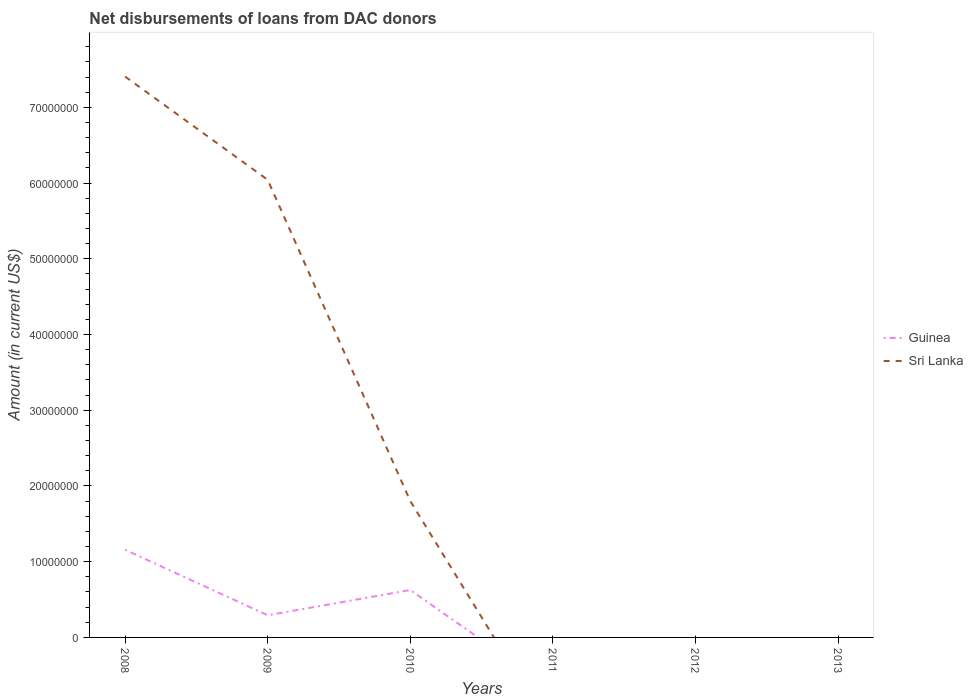Is the number of lines equal to the number of legend labels?
Your response must be concise. No. Across all years, what is the maximum amount of loans disbursed in Guinea?
Your answer should be very brief. 0. What is the difference between the highest and the second highest amount of loans disbursed in Sri Lanka?
Your response must be concise. 7.41e+07. What is the difference between the highest and the lowest amount of loans disbursed in Sri Lanka?
Provide a short and direct response. 2. Is the amount of loans disbursed in Sri Lanka strictly greater than the amount of loans disbursed in Guinea over the years?
Your answer should be compact. No. Are the values on the major ticks of Y-axis written in scientific E-notation?
Provide a short and direct response. No. How are the legend labels stacked?
Your response must be concise. Vertical. What is the title of the graph?
Give a very brief answer. Net disbursements of loans from DAC donors. What is the Amount (in current US$) of Guinea in 2008?
Your response must be concise. 1.16e+07. What is the Amount (in current US$) of Sri Lanka in 2008?
Your response must be concise. 7.41e+07. What is the Amount (in current US$) of Guinea in 2009?
Ensure brevity in your answer.  2.93e+06. What is the Amount (in current US$) of Sri Lanka in 2009?
Your answer should be very brief. 6.04e+07. What is the Amount (in current US$) of Guinea in 2010?
Make the answer very short. 6.26e+06. What is the Amount (in current US$) of Sri Lanka in 2010?
Your answer should be compact. 1.80e+07. What is the Amount (in current US$) of Guinea in 2011?
Ensure brevity in your answer.  0. What is the Amount (in current US$) of Sri Lanka in 2012?
Provide a succinct answer. 0. Across all years, what is the maximum Amount (in current US$) in Guinea?
Offer a very short reply. 1.16e+07. Across all years, what is the maximum Amount (in current US$) in Sri Lanka?
Provide a succinct answer. 7.41e+07. Across all years, what is the minimum Amount (in current US$) of Guinea?
Ensure brevity in your answer.  0. Across all years, what is the minimum Amount (in current US$) of Sri Lanka?
Make the answer very short. 0. What is the total Amount (in current US$) in Guinea in the graph?
Keep it short and to the point. 2.08e+07. What is the total Amount (in current US$) of Sri Lanka in the graph?
Give a very brief answer. 1.52e+08. What is the difference between the Amount (in current US$) of Guinea in 2008 and that in 2009?
Your answer should be compact. 8.64e+06. What is the difference between the Amount (in current US$) of Sri Lanka in 2008 and that in 2009?
Provide a short and direct response. 1.36e+07. What is the difference between the Amount (in current US$) of Guinea in 2008 and that in 2010?
Your answer should be compact. 5.31e+06. What is the difference between the Amount (in current US$) in Sri Lanka in 2008 and that in 2010?
Give a very brief answer. 5.60e+07. What is the difference between the Amount (in current US$) of Guinea in 2009 and that in 2010?
Offer a terse response. -3.33e+06. What is the difference between the Amount (in current US$) in Sri Lanka in 2009 and that in 2010?
Give a very brief answer. 4.24e+07. What is the difference between the Amount (in current US$) in Guinea in 2008 and the Amount (in current US$) in Sri Lanka in 2009?
Your answer should be very brief. -4.89e+07. What is the difference between the Amount (in current US$) of Guinea in 2008 and the Amount (in current US$) of Sri Lanka in 2010?
Offer a very short reply. -6.44e+06. What is the difference between the Amount (in current US$) in Guinea in 2009 and the Amount (in current US$) in Sri Lanka in 2010?
Ensure brevity in your answer.  -1.51e+07. What is the average Amount (in current US$) in Guinea per year?
Provide a succinct answer. 3.46e+06. What is the average Amount (in current US$) in Sri Lanka per year?
Give a very brief answer. 2.54e+07. In the year 2008, what is the difference between the Amount (in current US$) in Guinea and Amount (in current US$) in Sri Lanka?
Make the answer very short. -6.25e+07. In the year 2009, what is the difference between the Amount (in current US$) in Guinea and Amount (in current US$) in Sri Lanka?
Provide a short and direct response. -5.75e+07. In the year 2010, what is the difference between the Amount (in current US$) in Guinea and Amount (in current US$) in Sri Lanka?
Offer a terse response. -1.18e+07. What is the ratio of the Amount (in current US$) of Guinea in 2008 to that in 2009?
Your answer should be compact. 3.95. What is the ratio of the Amount (in current US$) of Sri Lanka in 2008 to that in 2009?
Make the answer very short. 1.23. What is the ratio of the Amount (in current US$) of Guinea in 2008 to that in 2010?
Your answer should be compact. 1.85. What is the ratio of the Amount (in current US$) of Sri Lanka in 2008 to that in 2010?
Keep it short and to the point. 4.11. What is the ratio of the Amount (in current US$) in Guinea in 2009 to that in 2010?
Ensure brevity in your answer.  0.47. What is the ratio of the Amount (in current US$) in Sri Lanka in 2009 to that in 2010?
Provide a short and direct response. 3.35. What is the difference between the highest and the second highest Amount (in current US$) of Guinea?
Provide a short and direct response. 5.31e+06. What is the difference between the highest and the second highest Amount (in current US$) of Sri Lanka?
Make the answer very short. 1.36e+07. What is the difference between the highest and the lowest Amount (in current US$) in Guinea?
Make the answer very short. 1.16e+07. What is the difference between the highest and the lowest Amount (in current US$) in Sri Lanka?
Provide a short and direct response. 7.41e+07. 